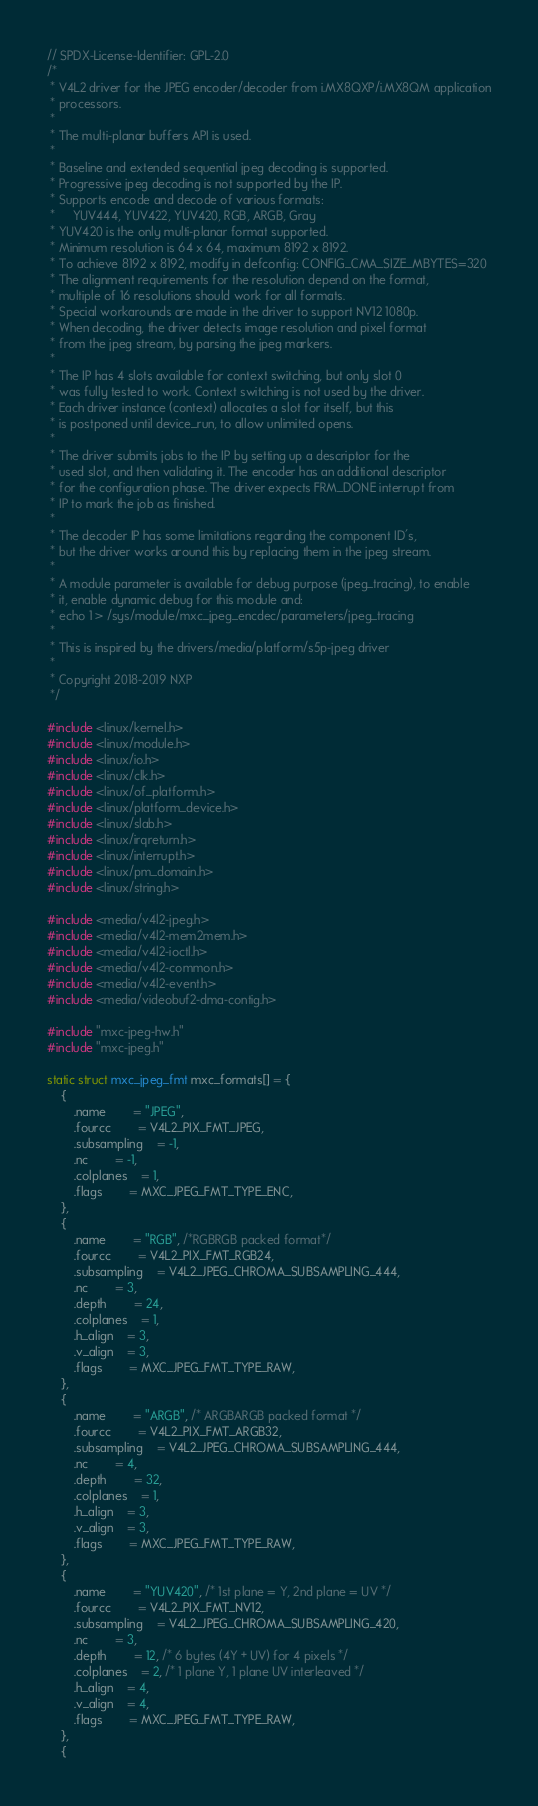Convert code to text. <code><loc_0><loc_0><loc_500><loc_500><_C_>// SPDX-License-Identifier: GPL-2.0
/*
 * V4L2 driver for the JPEG encoder/decoder from i.MX8QXP/i.MX8QM application
 * processors.
 *
 * The multi-planar buffers API is used.
 *
 * Baseline and extended sequential jpeg decoding is supported.
 * Progressive jpeg decoding is not supported by the IP.
 * Supports encode and decode of various formats:
 *     YUV444, YUV422, YUV420, RGB, ARGB, Gray
 * YUV420 is the only multi-planar format supported.
 * Minimum resolution is 64 x 64, maximum 8192 x 8192.
 * To achieve 8192 x 8192, modify in defconfig: CONFIG_CMA_SIZE_MBYTES=320
 * The alignment requirements for the resolution depend on the format,
 * multiple of 16 resolutions should work for all formats.
 * Special workarounds are made in the driver to support NV12 1080p.
 * When decoding, the driver detects image resolution and pixel format
 * from the jpeg stream, by parsing the jpeg markers.
 *
 * The IP has 4 slots available for context switching, but only slot 0
 * was fully tested to work. Context switching is not used by the driver.
 * Each driver instance (context) allocates a slot for itself, but this
 * is postponed until device_run, to allow unlimited opens.
 *
 * The driver submits jobs to the IP by setting up a descriptor for the
 * used slot, and then validating it. The encoder has an additional descriptor
 * for the configuration phase. The driver expects FRM_DONE interrupt from
 * IP to mark the job as finished.
 *
 * The decoder IP has some limitations regarding the component ID's,
 * but the driver works around this by replacing them in the jpeg stream.
 *
 * A module parameter is available for debug purpose (jpeg_tracing), to enable
 * it, enable dynamic debug for this module and:
 * echo 1 > /sys/module/mxc_jpeg_encdec/parameters/jpeg_tracing
 *
 * This is inspired by the drivers/media/platform/s5p-jpeg driver
 *
 * Copyright 2018-2019 NXP
 */

#include <linux/kernel.h>
#include <linux/module.h>
#include <linux/io.h>
#include <linux/clk.h>
#include <linux/of_platform.h>
#include <linux/platform_device.h>
#include <linux/slab.h>
#include <linux/irqreturn.h>
#include <linux/interrupt.h>
#include <linux/pm_domain.h>
#include <linux/string.h>

#include <media/v4l2-jpeg.h>
#include <media/v4l2-mem2mem.h>
#include <media/v4l2-ioctl.h>
#include <media/v4l2-common.h>
#include <media/v4l2-event.h>
#include <media/videobuf2-dma-contig.h>

#include "mxc-jpeg-hw.h"
#include "mxc-jpeg.h"

static struct mxc_jpeg_fmt mxc_formats[] = {
	{
		.name		= "JPEG",
		.fourcc		= V4L2_PIX_FMT_JPEG,
		.subsampling	= -1,
		.nc		= -1,
		.colplanes	= 1,
		.flags		= MXC_JPEG_FMT_TYPE_ENC,
	},
	{
		.name		= "RGB", /*RGBRGB packed format*/
		.fourcc		= V4L2_PIX_FMT_RGB24,
		.subsampling	= V4L2_JPEG_CHROMA_SUBSAMPLING_444,
		.nc		= 3,
		.depth		= 24,
		.colplanes	= 1,
		.h_align	= 3,
		.v_align	= 3,
		.flags		= MXC_JPEG_FMT_TYPE_RAW,
	},
	{
		.name		= "ARGB", /* ARGBARGB packed format */
		.fourcc		= V4L2_PIX_FMT_ARGB32,
		.subsampling	= V4L2_JPEG_CHROMA_SUBSAMPLING_444,
		.nc		= 4,
		.depth		= 32,
		.colplanes	= 1,
		.h_align	= 3,
		.v_align	= 3,
		.flags		= MXC_JPEG_FMT_TYPE_RAW,
	},
	{
		.name		= "YUV420", /* 1st plane = Y, 2nd plane = UV */
		.fourcc		= V4L2_PIX_FMT_NV12,
		.subsampling	= V4L2_JPEG_CHROMA_SUBSAMPLING_420,
		.nc		= 3,
		.depth		= 12, /* 6 bytes (4Y + UV) for 4 pixels */
		.colplanes	= 2, /* 1 plane Y, 1 plane UV interleaved */
		.h_align	= 4,
		.v_align	= 4,
		.flags		= MXC_JPEG_FMT_TYPE_RAW,
	},
	{</code> 